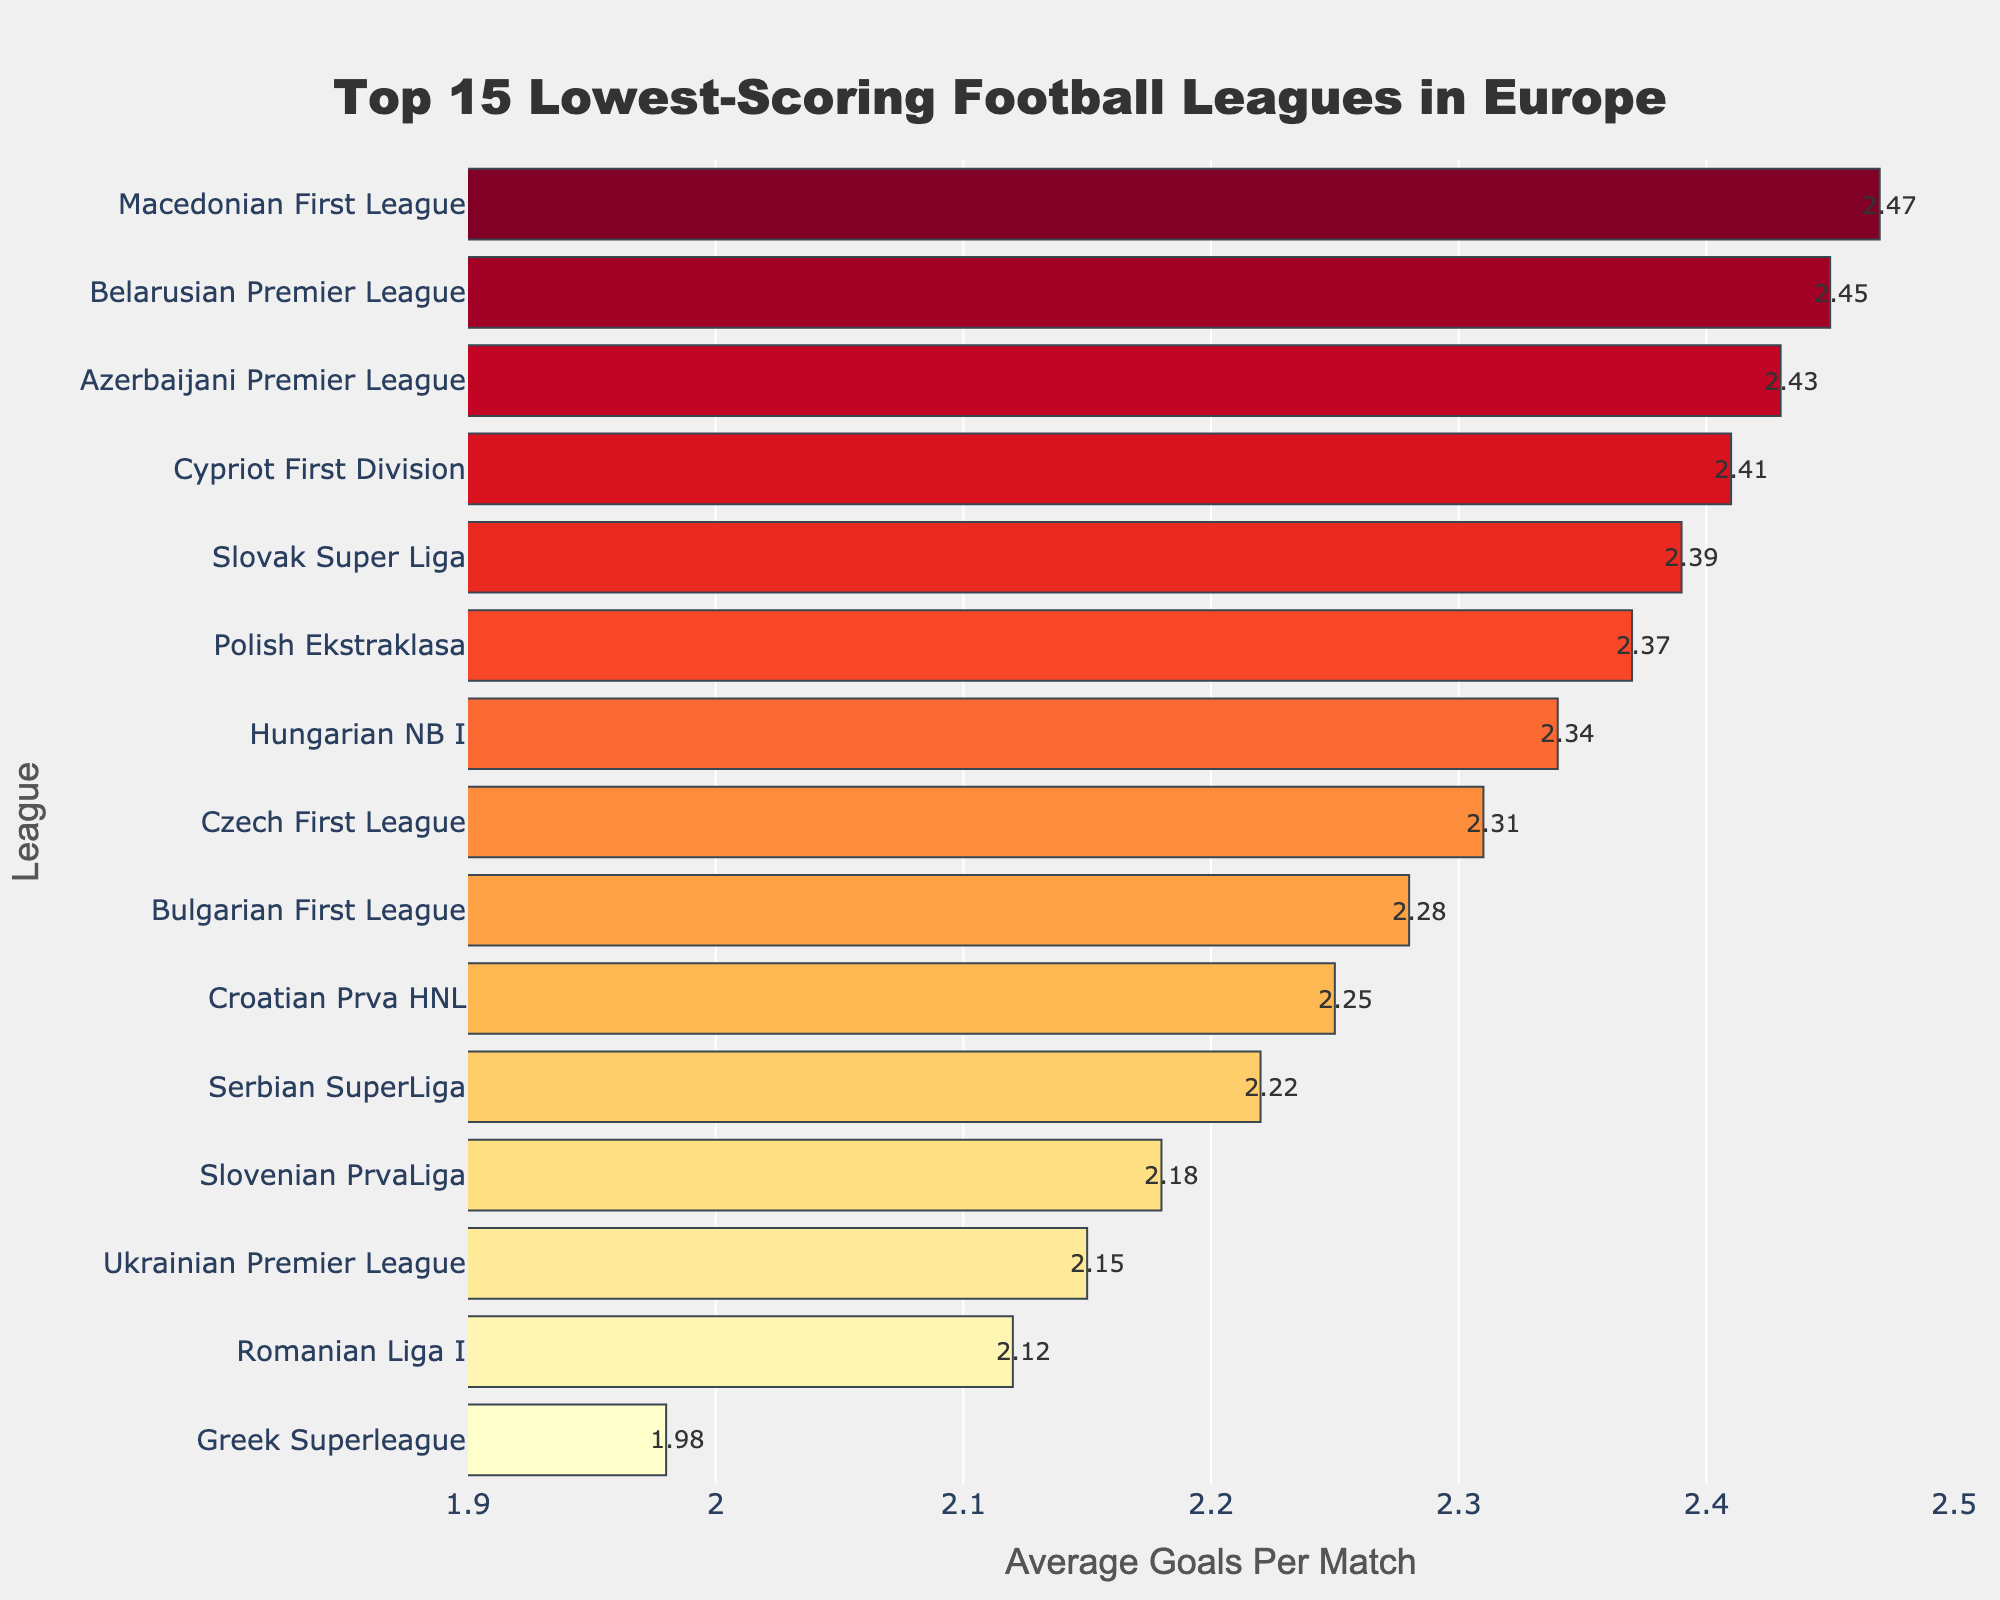what is the league with the lowest average goals per match? The bar chart shows the Greek Superleague at the top with an average of 1.98 goals per match, indicating it is the league with the lowest average goals per match.
Answer: Greek Superleague Compare the average goals per match between the Serbian SuperLiga and the Croatian Prva HNL. Which one is lower? The Serbian SuperLiga has 2.22 average goals per match and the Croatian Prva HNL has 2.25. Since 2.22 is less than 2.25, the Serbian SuperLiga has a lower average goals per match.
Answer: Serbian SuperLiga How many leagues have an average of less than 2.25 goals per match? The leagues with less than 2.25 average goals per match are Greek Superleague (1.98), Romanian Liga I (2.12), Ukrainian Premier League (2.15), Slovenian PrvaLiga (2.18), Serbian SuperLiga (2.22). Counting these gives a total of 5 leagues.
Answer: 5 Which league has a higher average goals per match, the Bulgarian First League or the Polish Ekstraklasa? The Bulgarian First League has 2.28 average goals per match, and the Polish Ekstraklasa has 2.37. Since 2.37 is more than 2.28, the Polish Ekstraklasa has a higher average goals per match.
Answer: Polish Ekstraklasa What is the median average goals per match of the leagues listed? The sorted list by average goals per match is: 1.98, 2.12, 2.15, 2.18, 2.22, 2.25, 2.28, 2.31, 2.34, 2.37, 2.39, 2.41, 2.43, 2.45, 2.47. With 15 leagues, the median is the 8th value in the list: 2.31
Answer: 2.31 